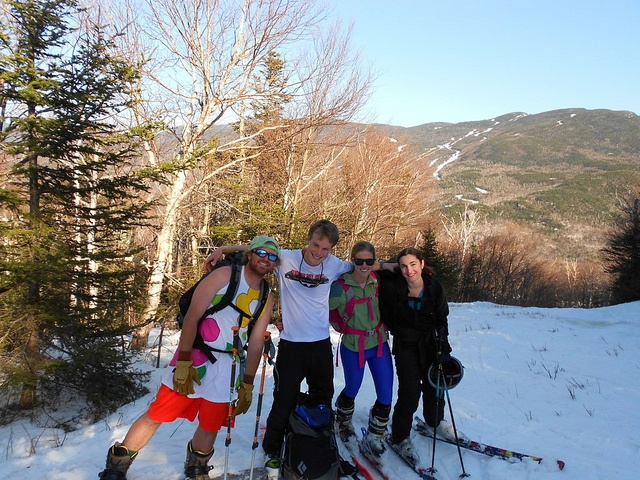Describe the objects in this image and their specific colors. I can see people in darkgray, black, maroon, and brown tones, people in darkgray, black, and gray tones, people in darkgray, black, gray, brown, and darkblue tones, people in darkgray, black, navy, gray, and purple tones, and backpack in darkgray, black, navy, gray, and darkblue tones in this image. 